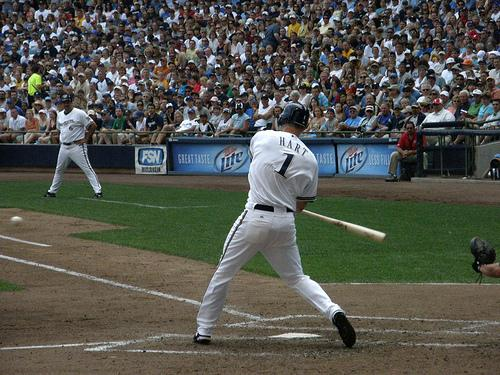According to the banner ad what kind of Lite beer tastes great? Please explain your reasoning. miller. The wording is visible with the slogan saying this and the logo of the company is also visible on the ad which connects the two. 